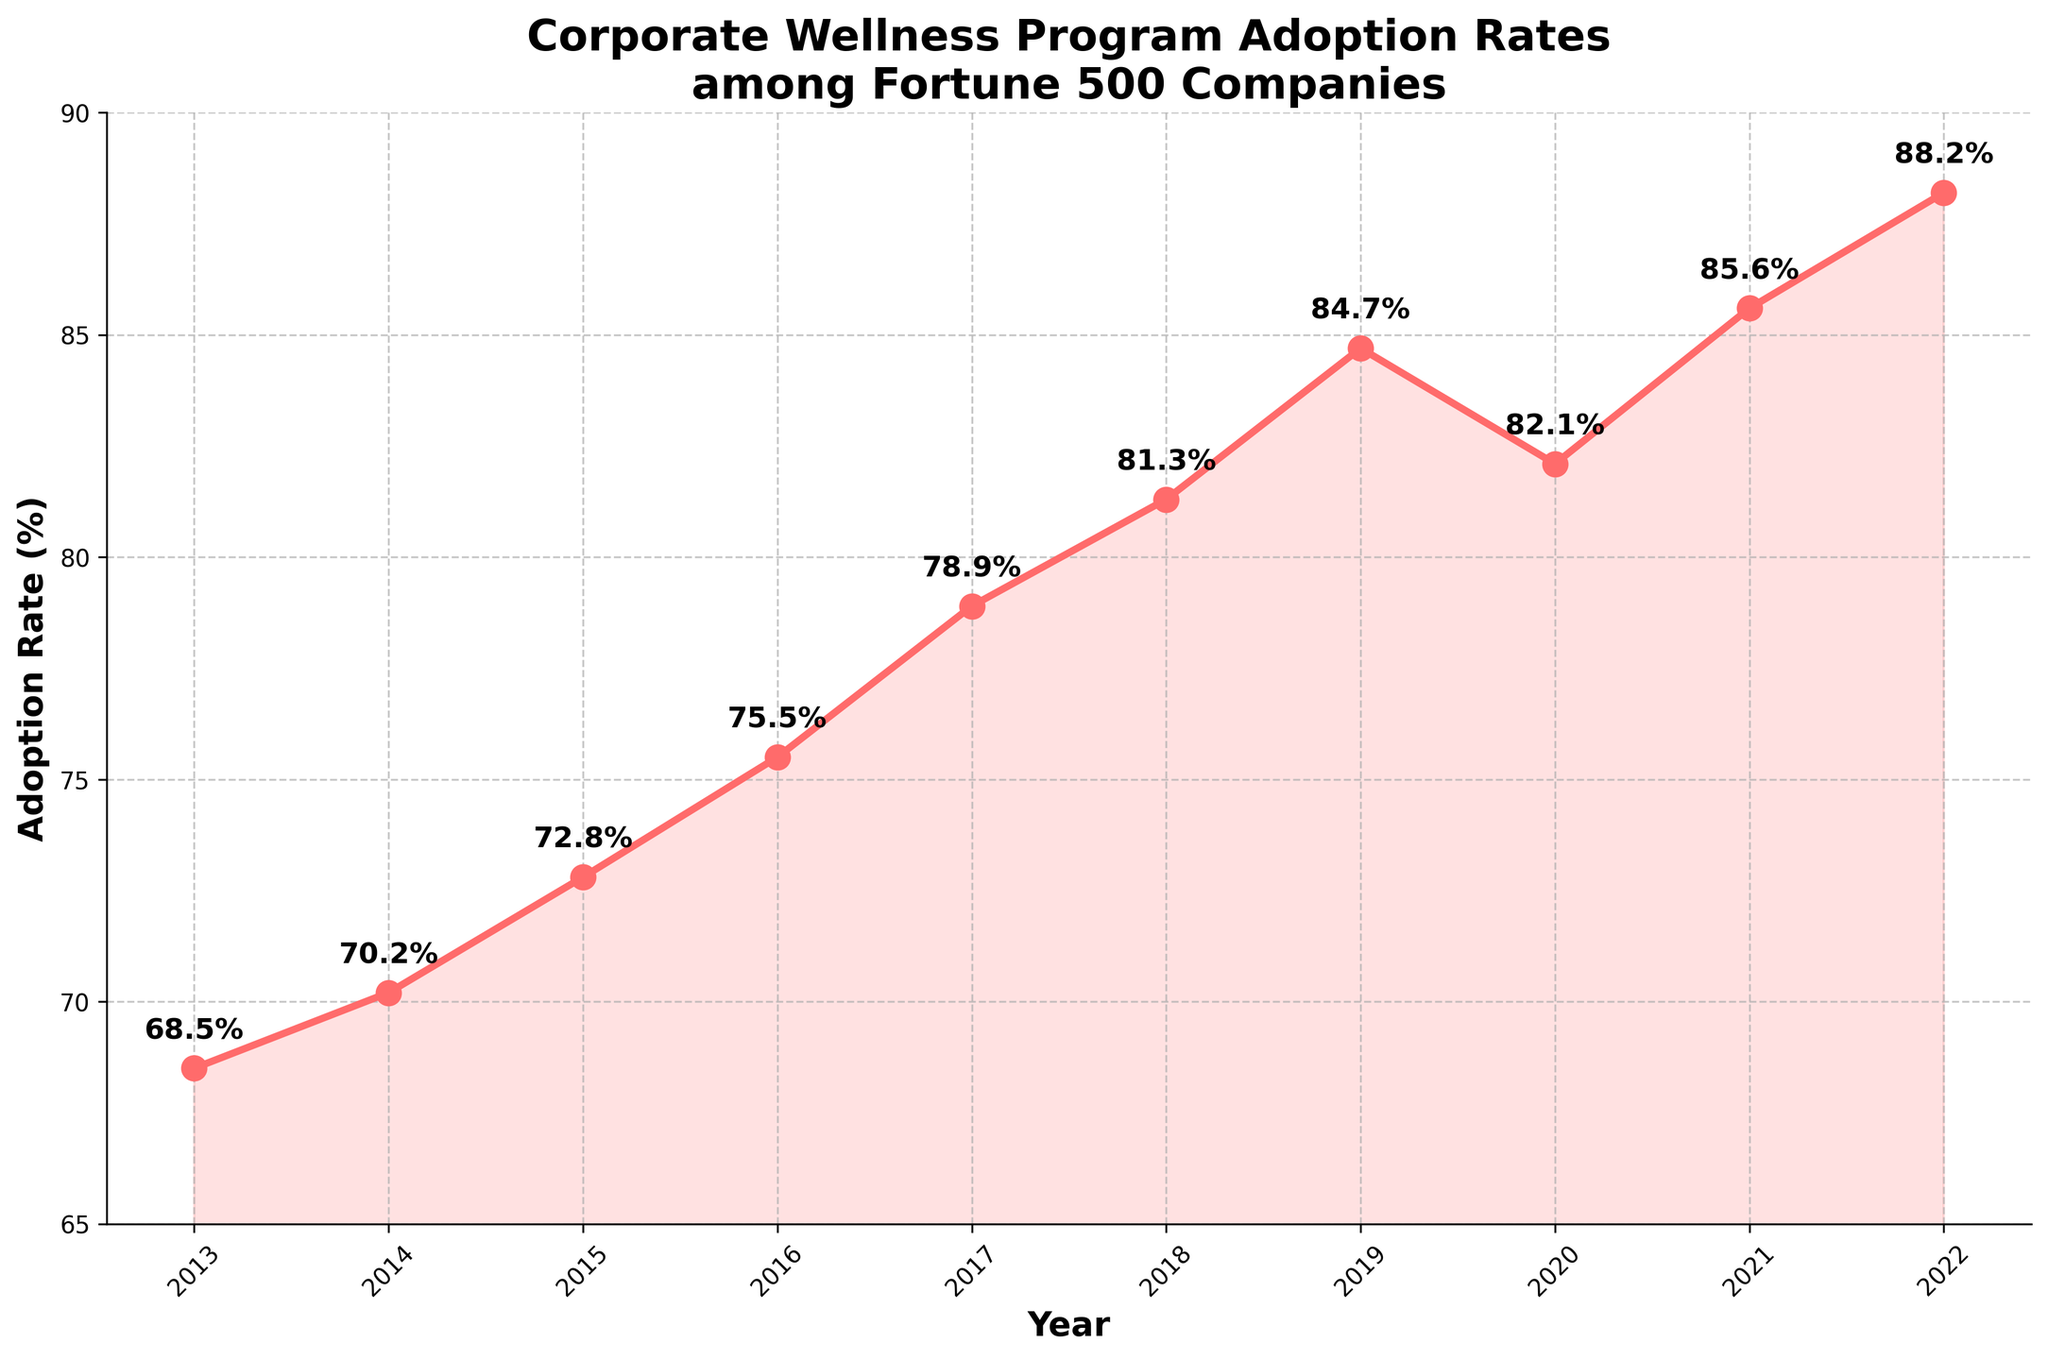What's the adoption rate in 2015? To find the adoption rate in 2015, refer to the data point on the line chart corresponding to the year 2015.
Answer: 72.8% Which year had the highest adoption rate? To determine which year had the highest adoption rate, observe all the data points on the chart and identify the maximum value.
Answer: 2022 How much did the adoption rate increase from 2014 to 2018? The adoption rate in 2014 is 70.2%, and in 2018 it's 81.3%. Calculate the difference: 81.3% - 70.2% = 11.1%.
Answer: 11.1% Did the adoption rate ever decline? If so, between which years? Examine the line chart to identify any downward trends. The adoption rate declines between 2019 and 2020.
Answer: Yes, 2019 to 2020 What's the average adoption rate from 2013 to 2022? Sum the adoption rates from 2013 to 2022 and divide by the number of years (10). (68.5% + 70.2% + 72.8% + 75.5% + 78.9% + 81.3% + 84.7% + 82.1% + 85.6% + 88.2%) / 10 = 78.78%
Answer: 78.78% By how much did the adoption rate change from 2019 to 2021? The adoption rate in 2019 is 84.7%, and in 2021 it's 85.6%. Calculate the difference: 85.6% - 84.7% = 0.9%.
Answer: 0.9% What is the median adoption rate over the years shown? Arrange the adoption rates in ascending order and find the middle value. For an even number of values (10 years), the median is the average of the 5th and 6th values: (78.9% + 81.3%) / 2 = 80.1%.
Answer: 80.1% Which year had a greater adoption rate, 2016 or 2020? Compare the data points for the years 2016 and 2020. 2016 has 75.5%, and 2020 has 82.1%.
Answer: 2020 How did the trend of adoption rates change over the years shown? Observe the overall shape of the line on the chart. The trend shows a general increase in adoption rates with a slight dip between 2019 and 2020.
Answer: Increasing with a slight dip between 2019 and 2020 From which year to which year is the steepest increase in adoption rate observed? Observe the line segments between each consecutive year and identify the steepest slope. The steepest increase is observed from 2018 to 2019 (81.3% to 84.7%).
Answer: 2018 to 2019 